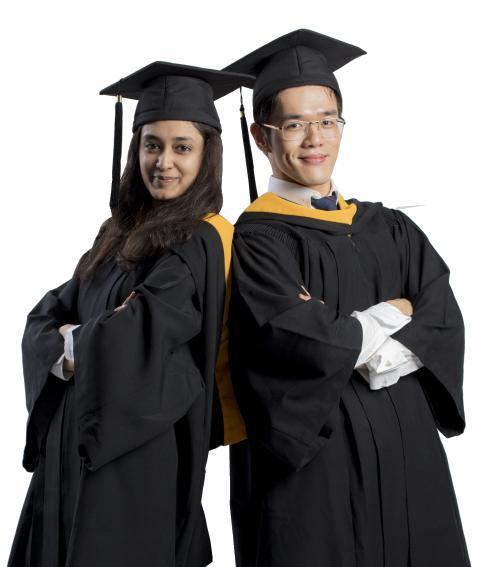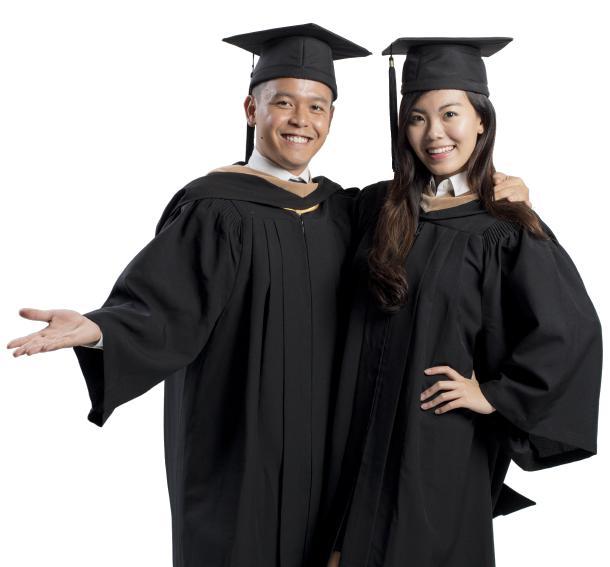The first image is the image on the left, the second image is the image on the right. For the images shown, is this caption "There are at least five people in total." true? Answer yes or no. No. The first image is the image on the left, the second image is the image on the right. Assess this claim about the two images: "There are atleast 5 people total". Correct or not? Answer yes or no. No. 